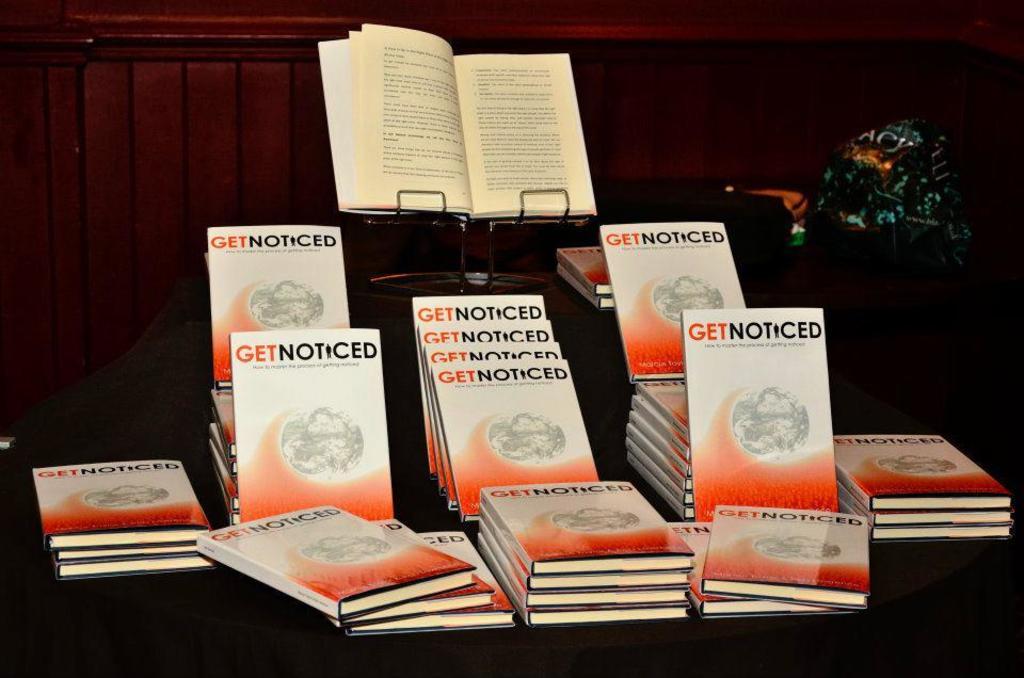What is the title of the books?
Offer a terse response. Get noticed. 